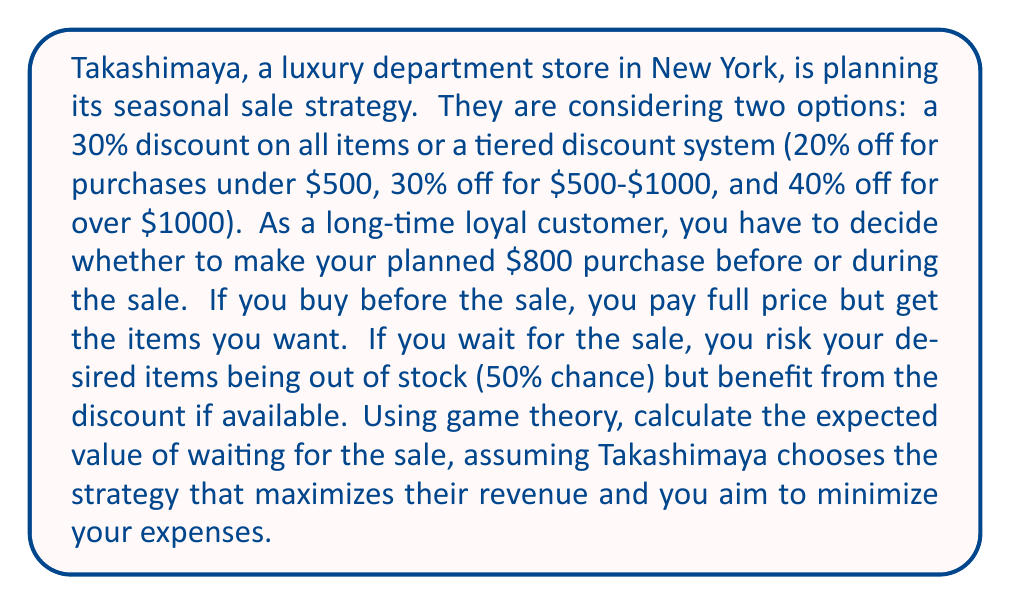Provide a solution to this math problem. Let's approach this step-by-step using game theory principles:

1) First, we need to set up the payoff matrix. The rows represent your choices (buy now or wait), and the columns represent Takashimaya's choices (30% flat discount or tiered discount).

2) If you buy now, you always pay $800, regardless of Takashimaya's choice.

3) If you wait and Takashimaya chooses the 30% flat discount:
   - 50% chance of items being in stock: $800 * (1 - 0.30) = $560
   - 50% chance of items being out of stock: $800 (full price later)
   Expected cost: $560 * 0.5 + $800 * 0.5 = $680

4) If you wait and Takashimaya chooses the tiered discount:
   - For $800 purchase, you fall in the 30% off tier
   - 50% chance of items being in stock: $800 * (1 - 0.30) = $560
   - 50% chance of items being out of stock: $800 (full price later)
   Expected cost: $560 * 0.5 + $800 * 0.5 = $680

5) The payoff matrix (from your perspective, lower is better) looks like this:

   $$
   \begin{bmatrix}
   800 & 800 \\
   680 & 680
   \end{bmatrix}
   $$

6) Takashimaya's goal is to maximize revenue, which is equivalent to maximizing your cost. They are indifferent between the two strategies as they result in the same expected revenue.

7) Your optimal strategy is to always wait for the sale, as it minimizes your expected cost regardless of Takashimaya's choice.

8) The expected value of waiting for the sale is therefore $680, which is $120 less than buying immediately.
Answer: The expected value of waiting for the sale is $680. 